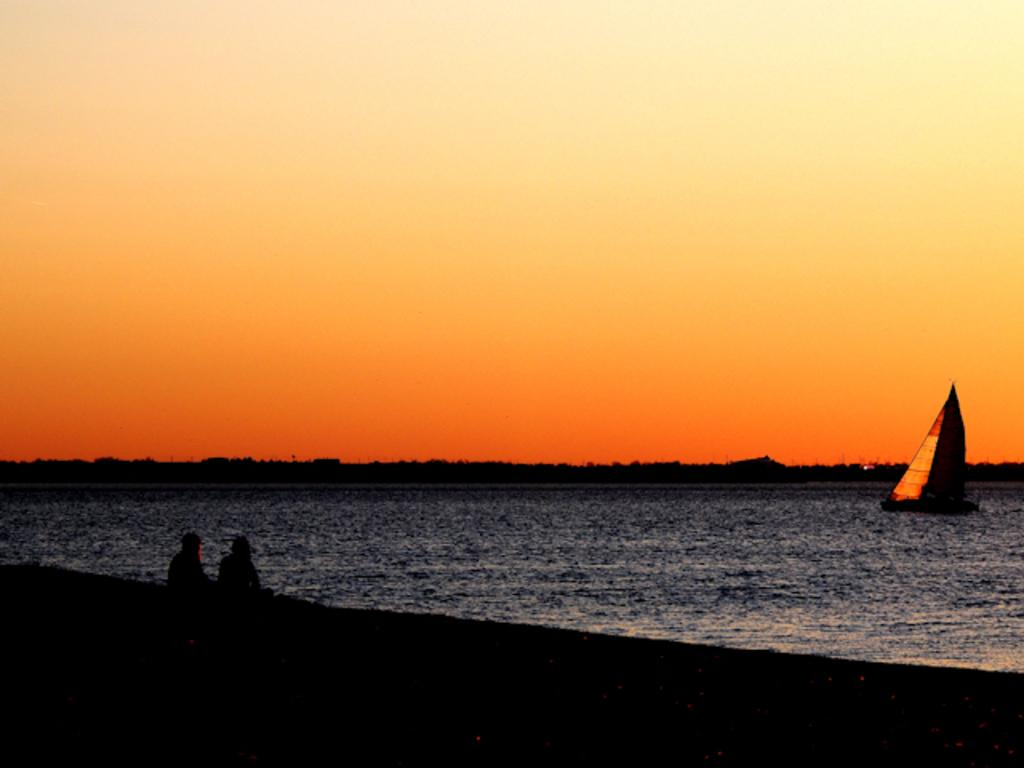What is the main subject of the image? The main subject of the image is a boat. Where is the boat located? The boat is in the water. How many people are in the boat? There are two people sitting in the boat. What is the color of the sky in the image? The sky is pale orange in the image. Where is the vase placed in the image? There is no vase present in the image. What type of trousers are the people in the boat wearing? The image does not show the clothing of the people in the boat, so we cannot determine the type of trousers they are wearing. 